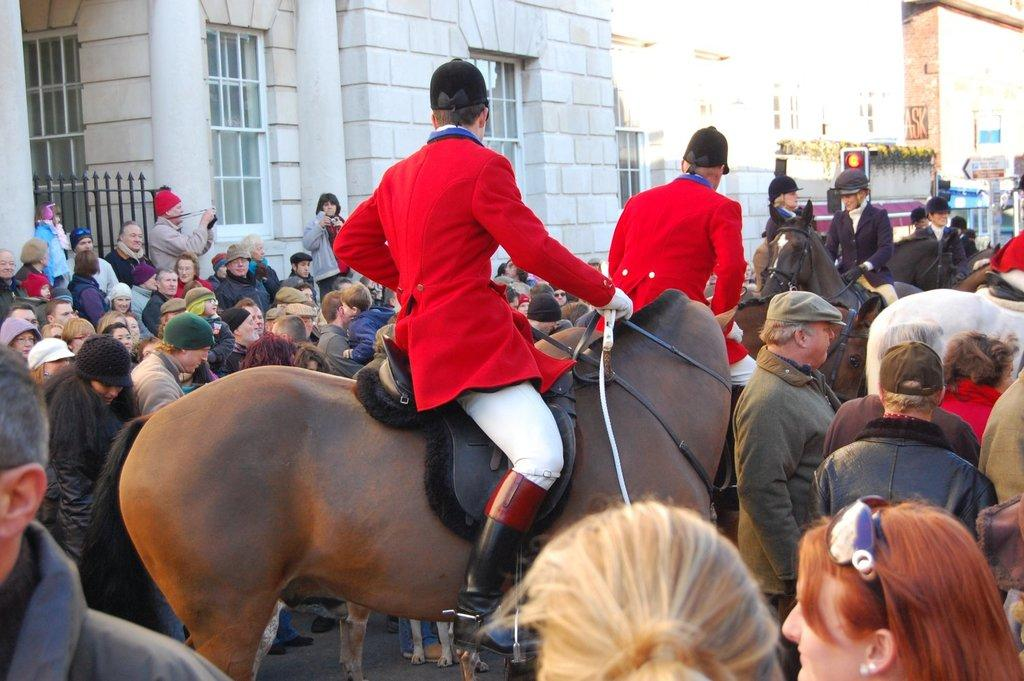What are the people doing in the image? The people are sitting on horses in the image. Are there any other people or animals in the image besides the ones on the horses? Yes, there are people gathered around the horses. What type of food is being served to the pigs in the image? There are no pigs or food present in the image; it features people sitting on horses with other people gathered around. 